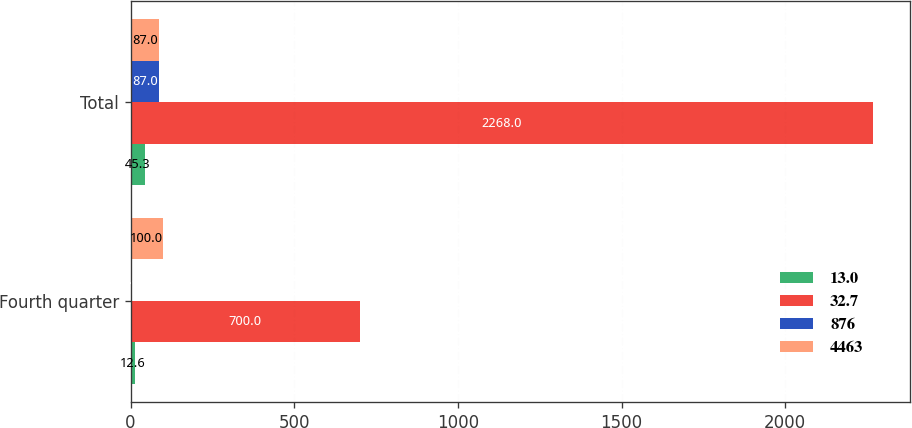<chart> <loc_0><loc_0><loc_500><loc_500><stacked_bar_chart><ecel><fcel>Fourth quarter<fcel>Total<nl><fcel>13<fcel>12.6<fcel>45.3<nl><fcel>32.7<fcel>700<fcel>2268<nl><fcel>876<fcel>1.8<fcel>87<nl><fcel>4463<fcel>100<fcel>87<nl></chart> 